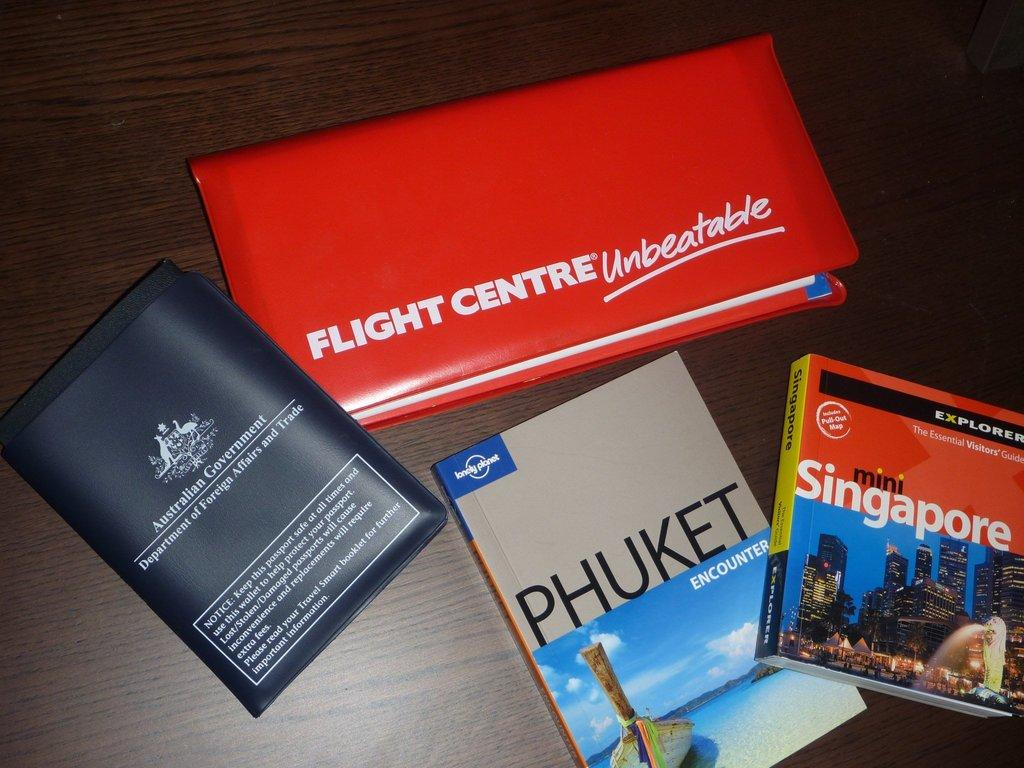Provide a one-sentence caption for the provided image. travel books to Phuket and Singapore along with a passport and red notebook with writing on it. 